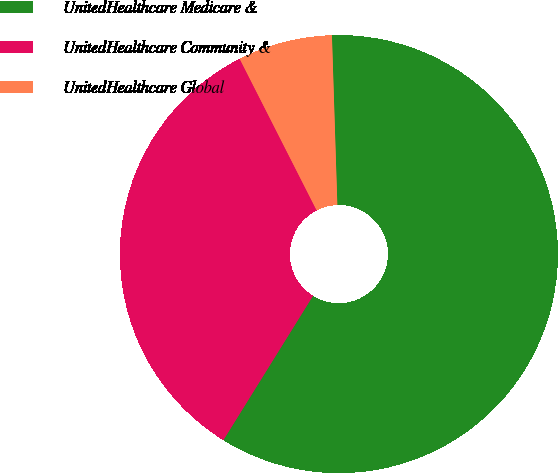<chart> <loc_0><loc_0><loc_500><loc_500><pie_chart><fcel>UnitedHealthcare Medicare &<fcel>UnitedHealthcare Community &<fcel>UnitedHealthcare Global<nl><fcel>59.35%<fcel>33.67%<fcel>6.97%<nl></chart> 